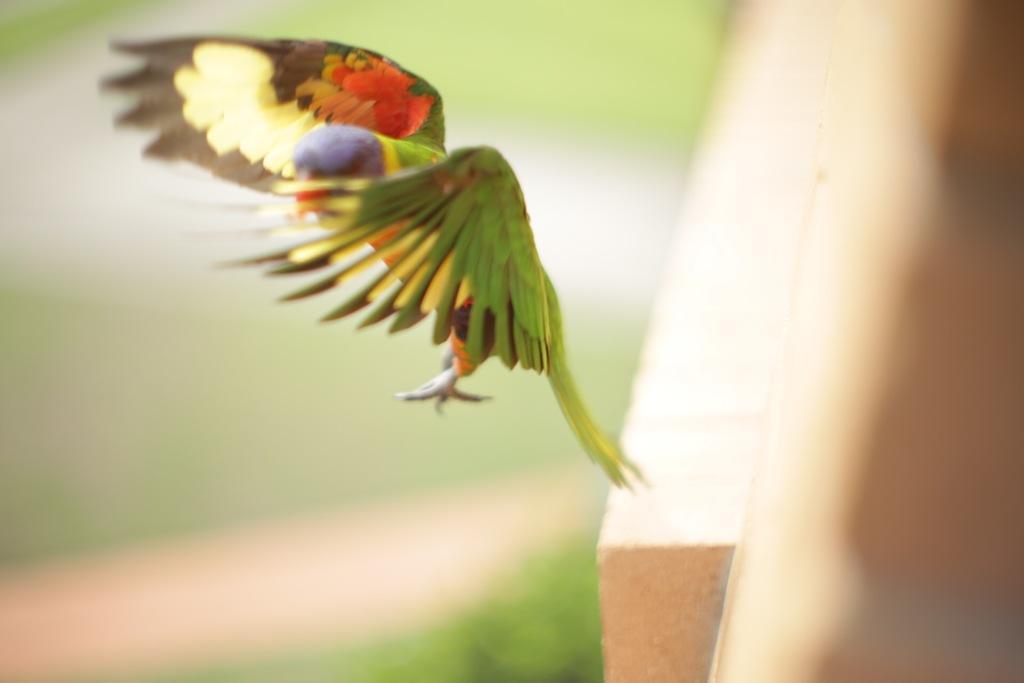Please provide a concise description of this image. As we can see in the image in the front there is a parrot and the background is blurred. 